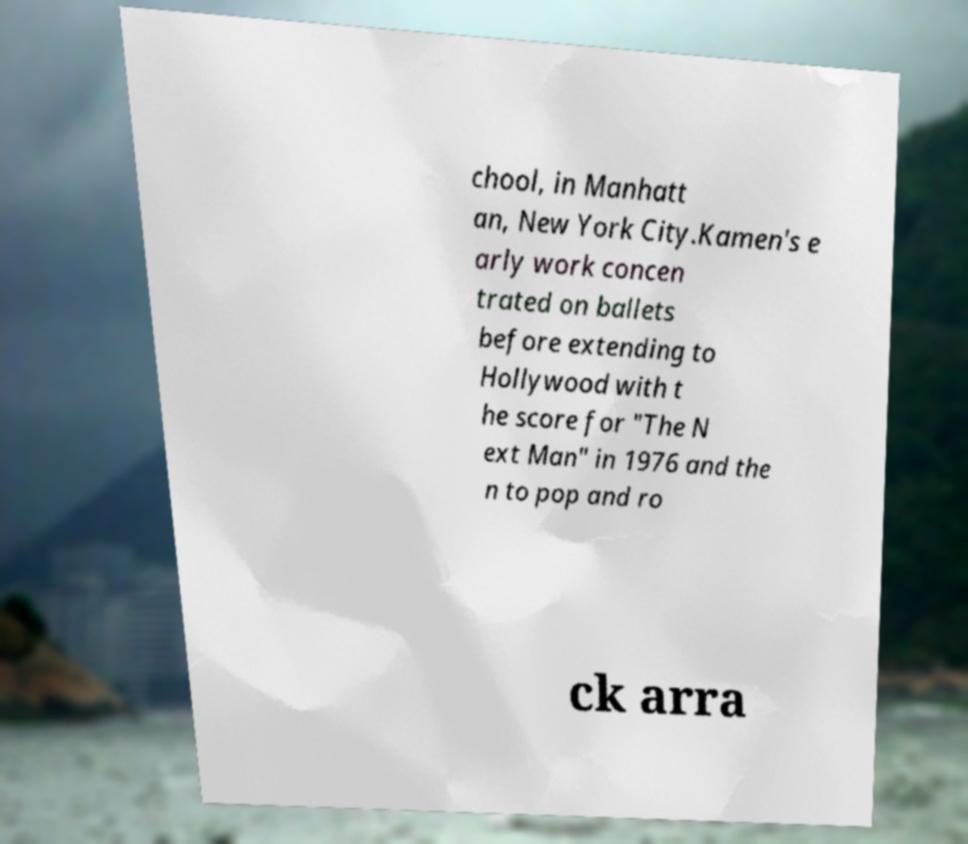Could you extract and type out the text from this image? chool, in Manhatt an, New York City.Kamen's e arly work concen trated on ballets before extending to Hollywood with t he score for "The N ext Man" in 1976 and the n to pop and ro ck arra 